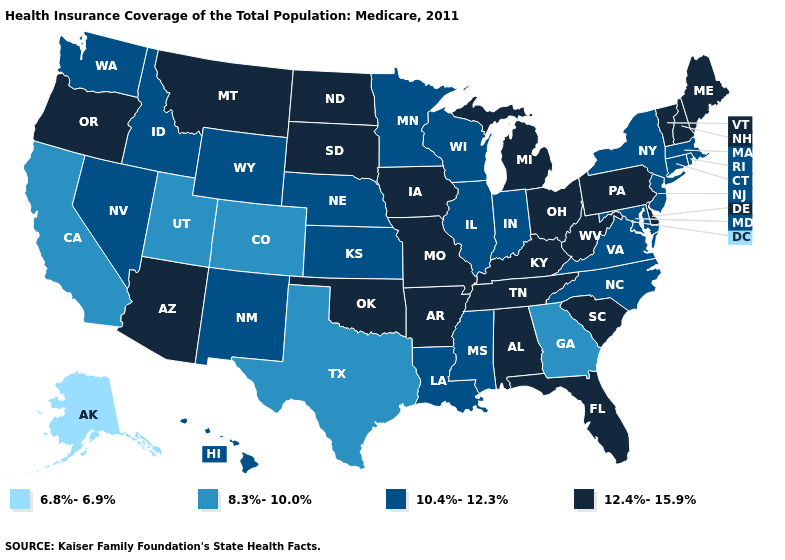What is the value of West Virginia?
Short answer required. 12.4%-15.9%. Name the states that have a value in the range 10.4%-12.3%?
Write a very short answer. Connecticut, Hawaii, Idaho, Illinois, Indiana, Kansas, Louisiana, Maryland, Massachusetts, Minnesota, Mississippi, Nebraska, Nevada, New Jersey, New Mexico, New York, North Carolina, Rhode Island, Virginia, Washington, Wisconsin, Wyoming. Does Pennsylvania have a higher value than Missouri?
Concise answer only. No. Name the states that have a value in the range 10.4%-12.3%?
Short answer required. Connecticut, Hawaii, Idaho, Illinois, Indiana, Kansas, Louisiana, Maryland, Massachusetts, Minnesota, Mississippi, Nebraska, Nevada, New Jersey, New Mexico, New York, North Carolina, Rhode Island, Virginia, Washington, Wisconsin, Wyoming. What is the value of Nebraska?
Write a very short answer. 10.4%-12.3%. Is the legend a continuous bar?
Be succinct. No. What is the lowest value in the Northeast?
Answer briefly. 10.4%-12.3%. Does the map have missing data?
Give a very brief answer. No. Among the states that border Kansas , does Oklahoma have the highest value?
Be succinct. Yes. Does Missouri have the lowest value in the MidWest?
Quick response, please. No. What is the value of Alabama?
Quick response, please. 12.4%-15.9%. What is the value of Mississippi?
Answer briefly. 10.4%-12.3%. What is the value of Colorado?
Answer briefly. 8.3%-10.0%. Does the map have missing data?
Concise answer only. No. What is the highest value in the Northeast ?
Short answer required. 12.4%-15.9%. 